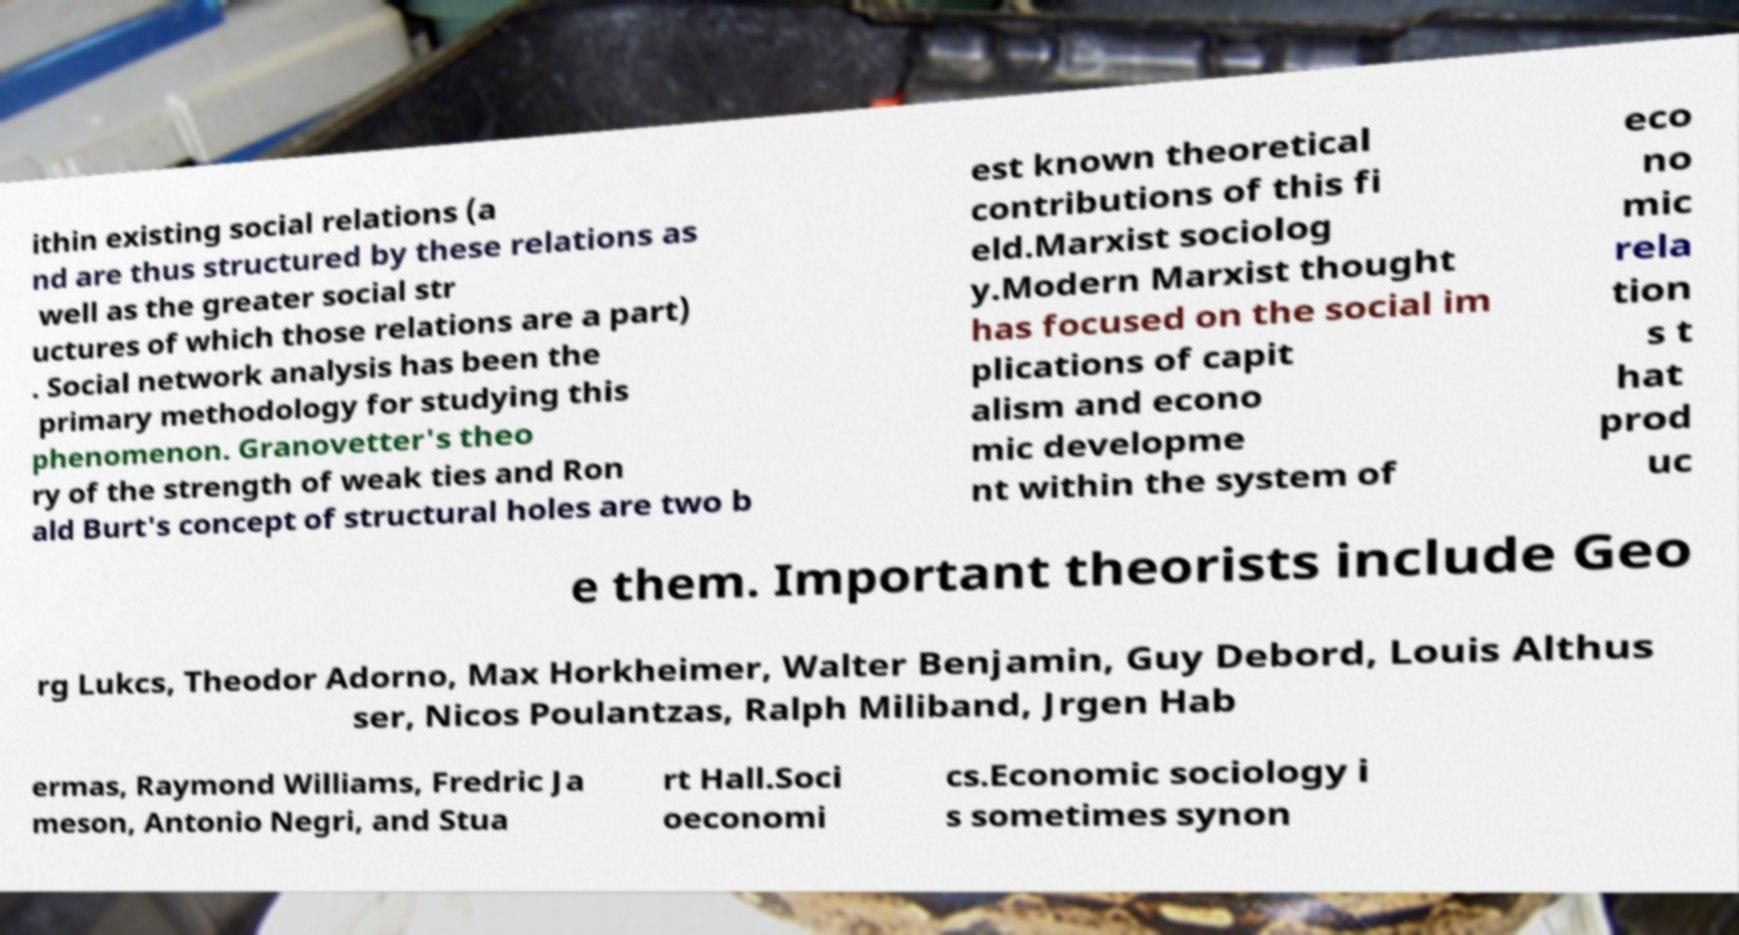Can you read and provide the text displayed in the image?This photo seems to have some interesting text. Can you extract and type it out for me? ithin existing social relations (a nd are thus structured by these relations as well as the greater social str uctures of which those relations are a part) . Social network analysis has been the primary methodology for studying this phenomenon. Granovetter's theo ry of the strength of weak ties and Ron ald Burt's concept of structural holes are two b est known theoretical contributions of this fi eld.Marxist sociolog y.Modern Marxist thought has focused on the social im plications of capit alism and econo mic developme nt within the system of eco no mic rela tion s t hat prod uc e them. Important theorists include Geo rg Lukcs, Theodor Adorno, Max Horkheimer, Walter Benjamin, Guy Debord, Louis Althus ser, Nicos Poulantzas, Ralph Miliband, Jrgen Hab ermas, Raymond Williams, Fredric Ja meson, Antonio Negri, and Stua rt Hall.Soci oeconomi cs.Economic sociology i s sometimes synon 